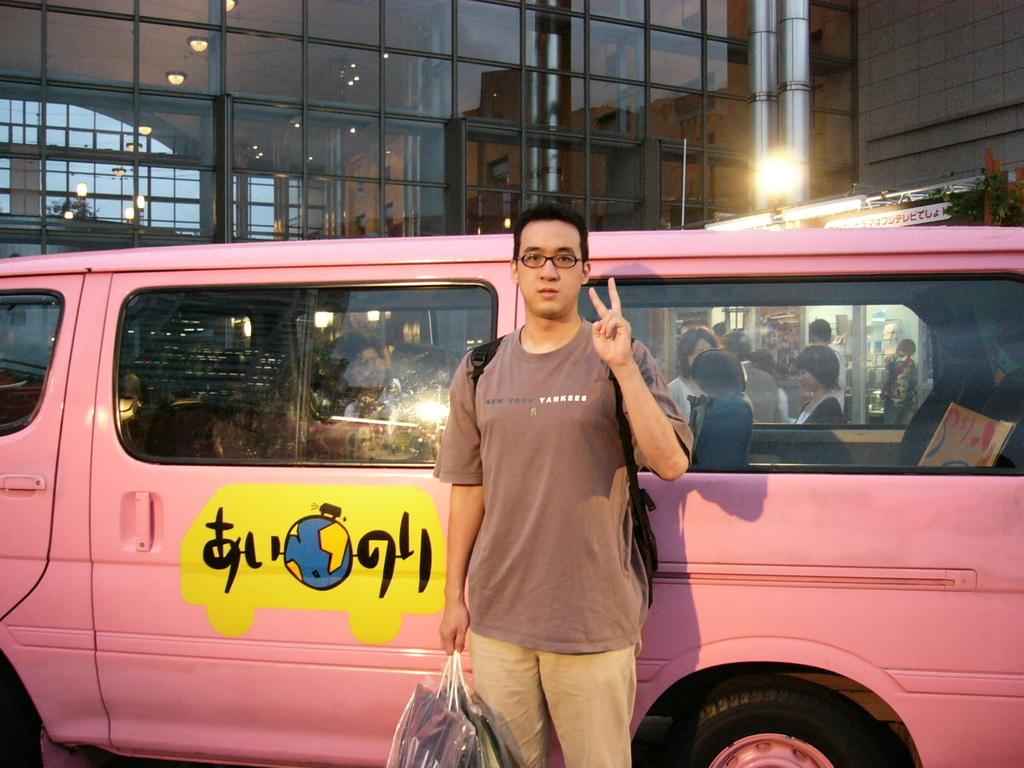<image>
Share a concise interpretation of the image provided. A man in a Yankees shirt stands in front of a pink vehicle. 